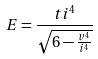<formula> <loc_0><loc_0><loc_500><loc_500>E = \frac { t i ^ { 4 } } { \sqrt { 6 - \frac { v ^ { 4 } } { i ^ { 4 } } } }</formula> 